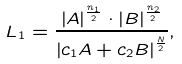<formula> <loc_0><loc_0><loc_500><loc_500>L _ { 1 } = \frac { \left | A \right | ^ { \frac { n _ { 1 } } { 2 } } \cdot \left | B \right | ^ { \frac { n _ { 2 } } { 2 } } } { \left | c _ { 1 } A + c _ { 2 } B \right | ^ { \frac { N } { 2 } } } ,</formula> 